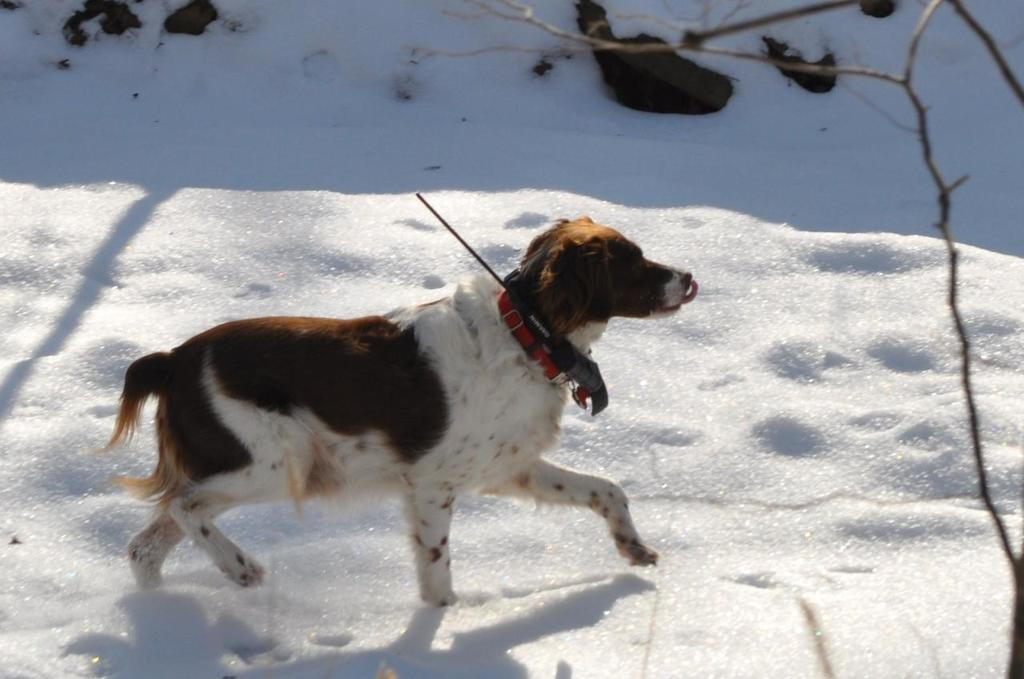What type of animal is in the image? There is a dog in the image. What is the dog doing in the image? The dog is standing on the ground. What is the condition of the ground in the image? There is snow on the ground. What type of invention can be seen in the image? There is no invention present in the image; it features a dog standing on snow-covered ground. How many sheep are visible in the image? There are no sheep present in the image; it features a dog standing on snow-covered ground. 